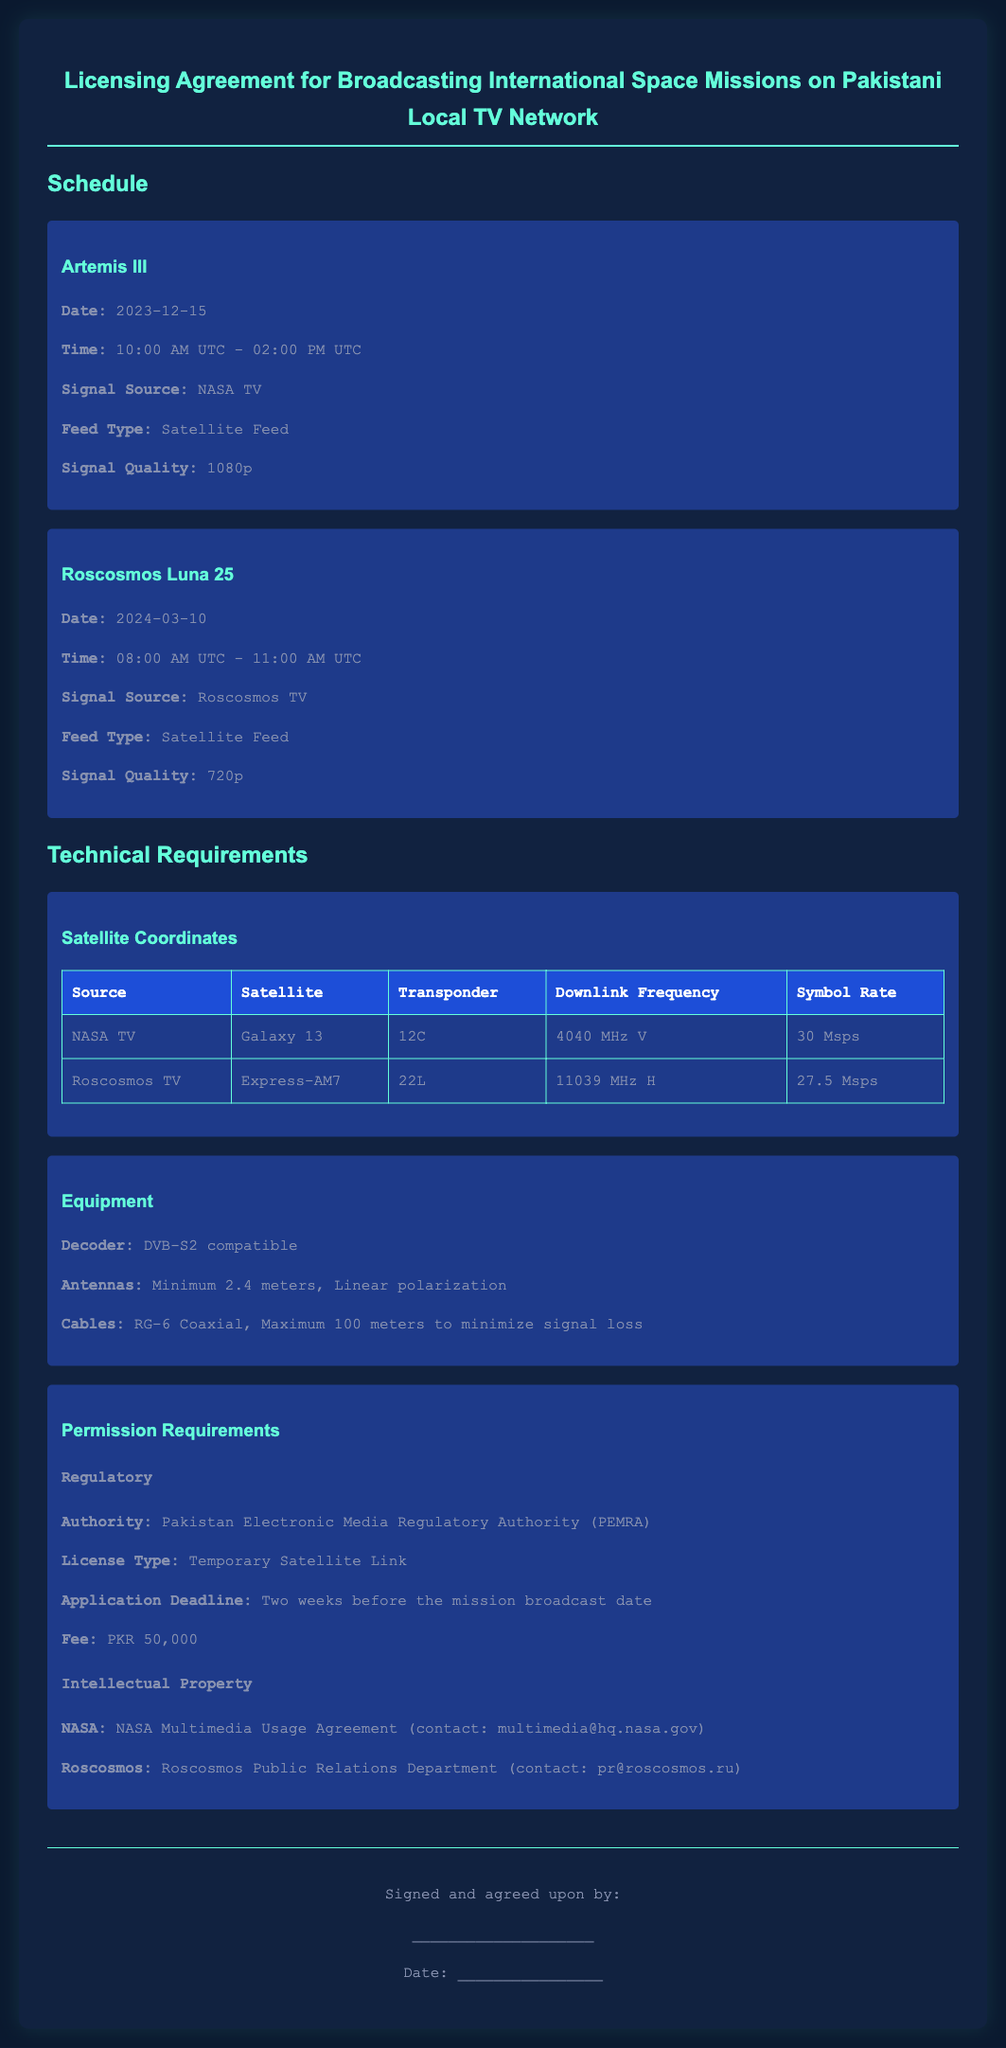what is the date of Artemis III? The date is specified in the document under the mission schedule, which states December 15, 2023.
Answer: December 15, 2023 what signal source is used for Roscosmos Luna 25? The document mentions that the signal source for Roscosmos Luna 25 is Roscosmos TV.
Answer: Roscosmos TV what is the maximum symbol rate for NASA TV? The document provides the symbol rate as 30 Msps for NASA TV.
Answer: 30 Msps which regulatory authority is mentioned for permission requirements? The document identifies the Pakistan Electronic Media Regulatory Authority (PEMRA) as the regulatory authority.
Answer: PEMRA what type of license is required for broadcasting? The license type is specified in the permission requirements as Temporary Satellite Link.
Answer: Temporary Satellite Link what is the contact email for NASA regarding intellectual property? The document states the contact for NASA as multimedia@hq.nasa.gov.
Answer: multimedia@hq.nasa.gov what is the signal quality for Roscosmos Luna 25? The document specifies the signal quality to be 720p for Roscosmos Luna 25.
Answer: 720p how many antennas are required as per the technical requirements? The requirement states a minimum of 2.4 meters for the antennas, not indicating a specific number but implies at least one.
Answer: Minimum 2.4 meters what is the application deadline for the license? The application deadline is mentioned as two weeks before the mission broadcast date.
Answer: Two weeks before the mission broadcast date 